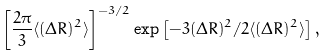<formula> <loc_0><loc_0><loc_500><loc_500>\left [ \frac { 2 \pi } { 3 } \langle ( \Delta R ) ^ { 2 } \rangle \right ] ^ { - 3 / 2 } \exp \left [ - 3 ( \Delta R ) ^ { 2 } / 2 \langle ( \Delta R ) ^ { 2 } \rangle \right ] ,</formula> 